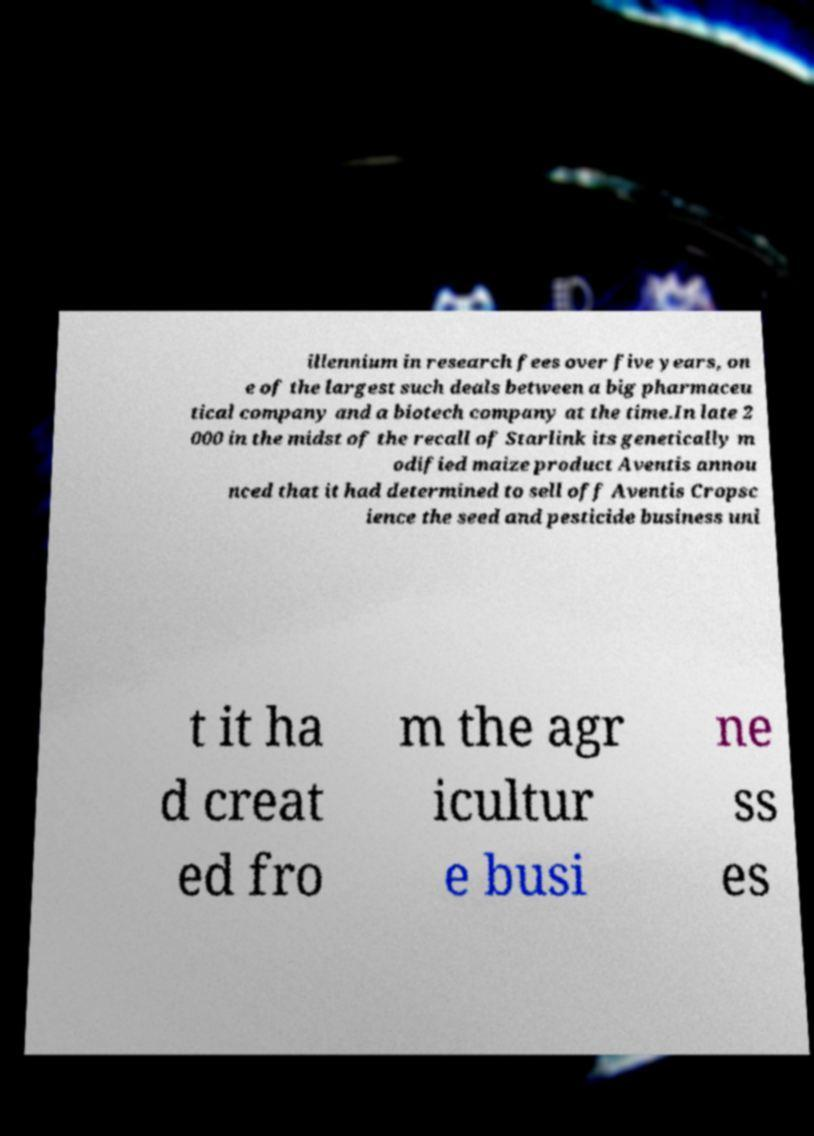Please identify and transcribe the text found in this image. illennium in research fees over five years, on e of the largest such deals between a big pharmaceu tical company and a biotech company at the time.In late 2 000 in the midst of the recall of Starlink its genetically m odified maize product Aventis annou nced that it had determined to sell off Aventis Cropsc ience the seed and pesticide business uni t it ha d creat ed fro m the agr icultur e busi ne ss es 